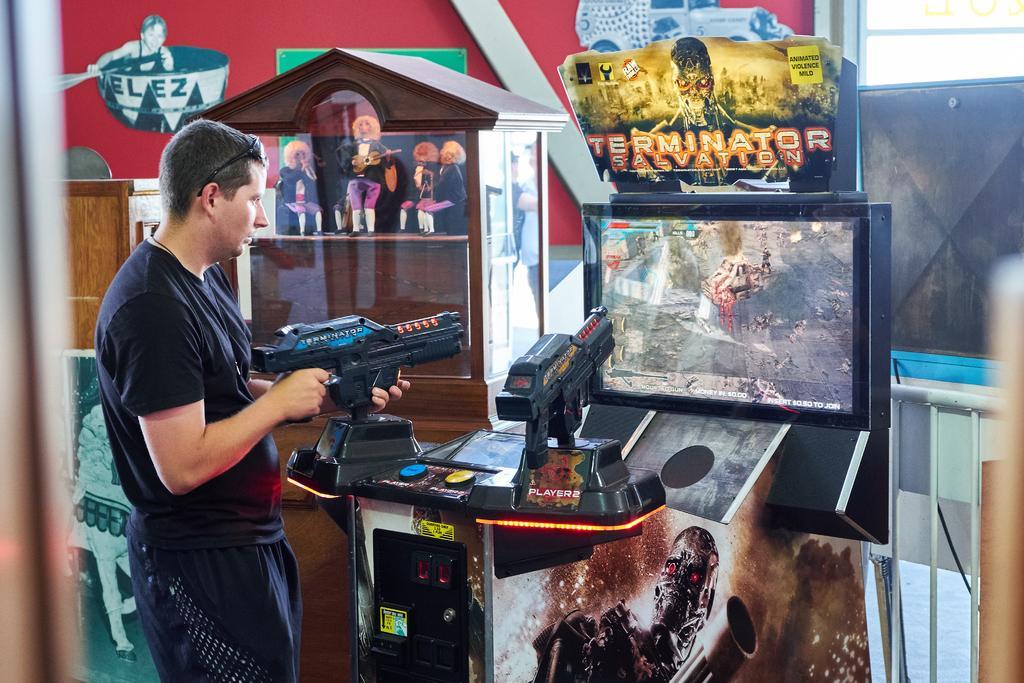In one or two sentences, can you explain what this image depicts? In the background we can see a screen, posters. Here we can see a man wearing a black t-shirt and here we can see goggles. 